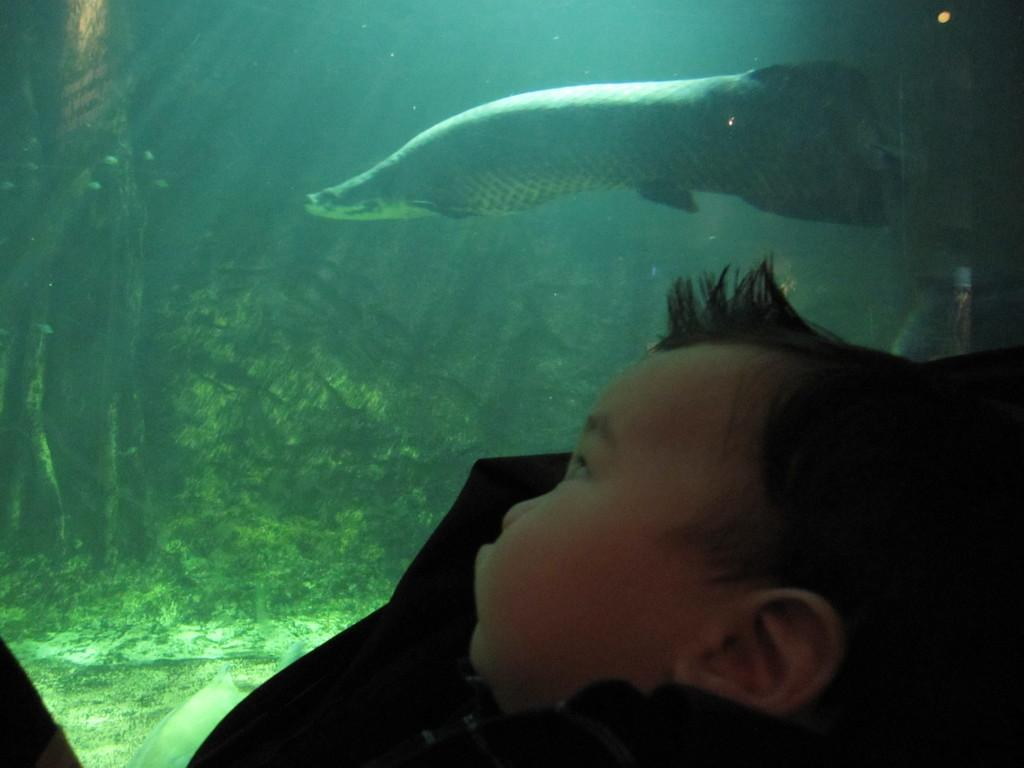What is the main subject of the picture? There is a baby in the picture. What can be seen in the background of the picture? There is an aquarium in the background of the picture. What is inside the aquarium? There is a fish swimming in the aquarium. Are there any other elements in the aquarium besides the fish? Yes, there are plants in the water of the aquarium. What type of doctor is examining the baby in the picture? There is no doctor present in the image; it only features a baby and an aquarium in the background. Can you see any lizards in the picture? No, there are no lizards present in the image. 